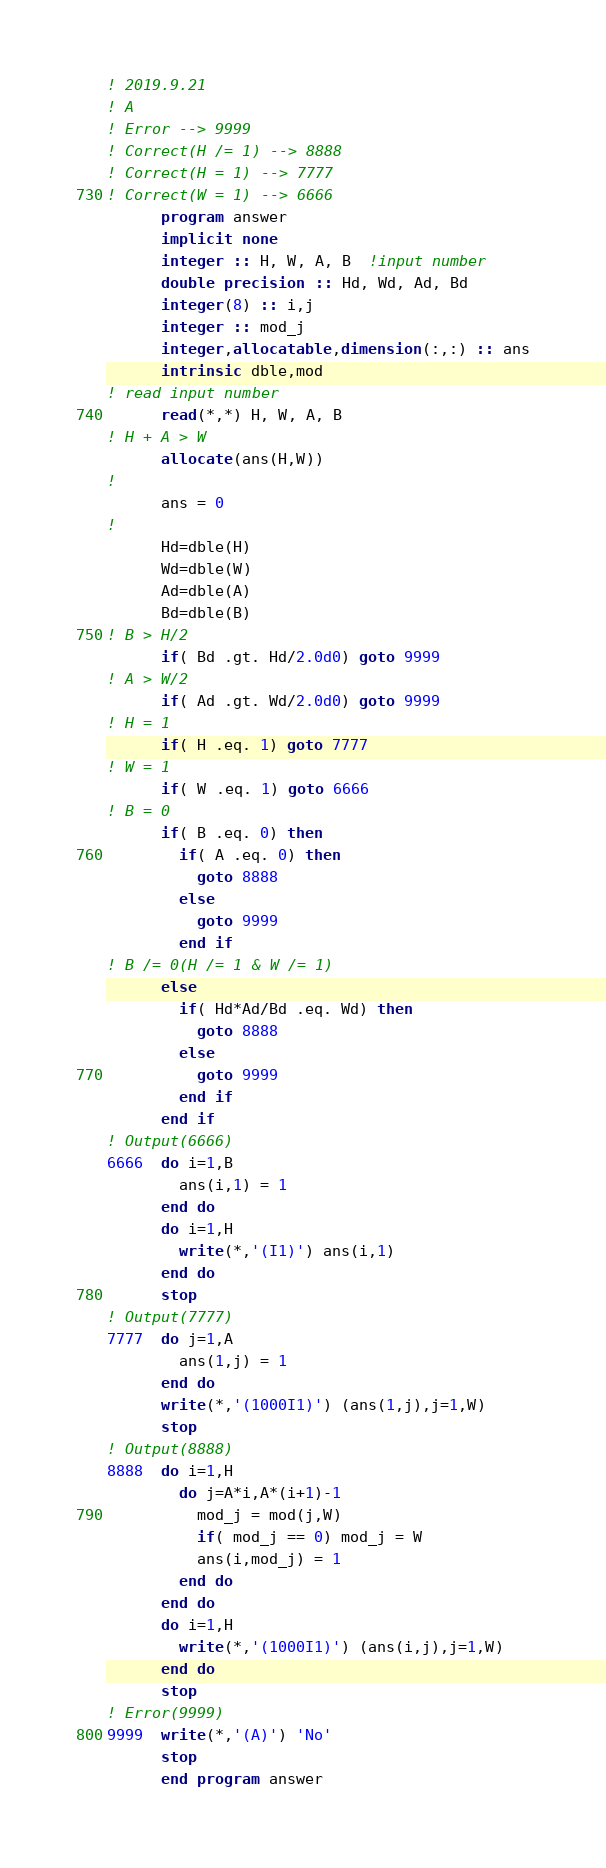<code> <loc_0><loc_0><loc_500><loc_500><_FORTRAN_>! 2019.9.21 
! A
! Error --> 9999
! Correct(H /= 1) --> 8888
! Correct(H = 1) --> 7777
! Correct(W = 1) --> 6666
      program answer
      implicit none
      integer :: H, W, A, B  !input number
      double precision :: Hd, Wd, Ad, Bd
      integer(8) :: i,j
      integer :: mod_j
      integer,allocatable,dimension(:,:) :: ans
      intrinsic dble,mod
! read input number
      read(*,*) H, W, A, B
! H + A > W
      allocate(ans(H,W))
!
      ans = 0
!
      Hd=dble(H)
      Wd=dble(W)
      Ad=dble(A)
      Bd=dble(B)
! B > H/2
      if( Bd .gt. Hd/2.0d0) goto 9999
! A > W/2
      if( Ad .gt. Wd/2.0d0) goto 9999
! H = 1
      if( H .eq. 1) goto 7777
! W = 1
      if( W .eq. 1) goto 6666
! B = 0
      if( B .eq. 0) then
        if( A .eq. 0) then
          goto 8888
        else
          goto 9999
        end if
! B /= 0(H /= 1 & W /= 1)
      else
        if( Hd*Ad/Bd .eq. Wd) then
          goto 8888
        else
          goto 9999
        end if
      end if
! Output(6666)
6666  do i=1,B
        ans(i,1) = 1
      end do
      do i=1,H
        write(*,'(I1)') ans(i,1)
      end do
      stop
! Output(7777)
7777  do j=1,A
        ans(1,j) = 1
      end do
      write(*,'(1000I1)') (ans(1,j),j=1,W)
      stop
! Output(8888)
8888  do i=1,H
        do j=A*i,A*(i+1)-1
          mod_j = mod(j,W)
          if( mod_j == 0) mod_j = W
          ans(i,mod_j) = 1
        end do
      end do
      do i=1,H
        write(*,'(1000I1)') (ans(i,j),j=1,W)
      end do
      stop
! Error(9999)
9999  write(*,'(A)') 'No'
      stop
      end program answer</code> 